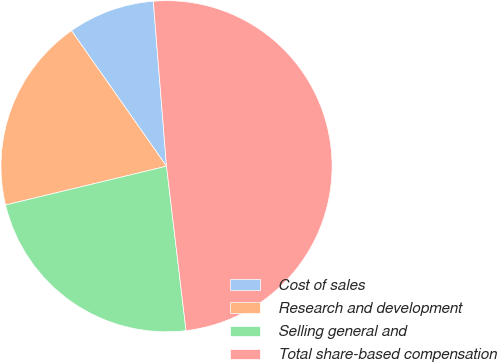Convert chart. <chart><loc_0><loc_0><loc_500><loc_500><pie_chart><fcel>Cost of sales<fcel>Research and development<fcel>Selling general and<fcel>Total share-based compensation<nl><fcel>8.46%<fcel>19.03%<fcel>23.12%<fcel>49.39%<nl></chart> 